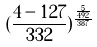<formula> <loc_0><loc_0><loc_500><loc_500>( \frac { 4 - 1 2 7 } { 3 3 2 } ) ^ { \frac { \frac { 5 } { 4 9 2 } } { 3 8 7 } }</formula> 